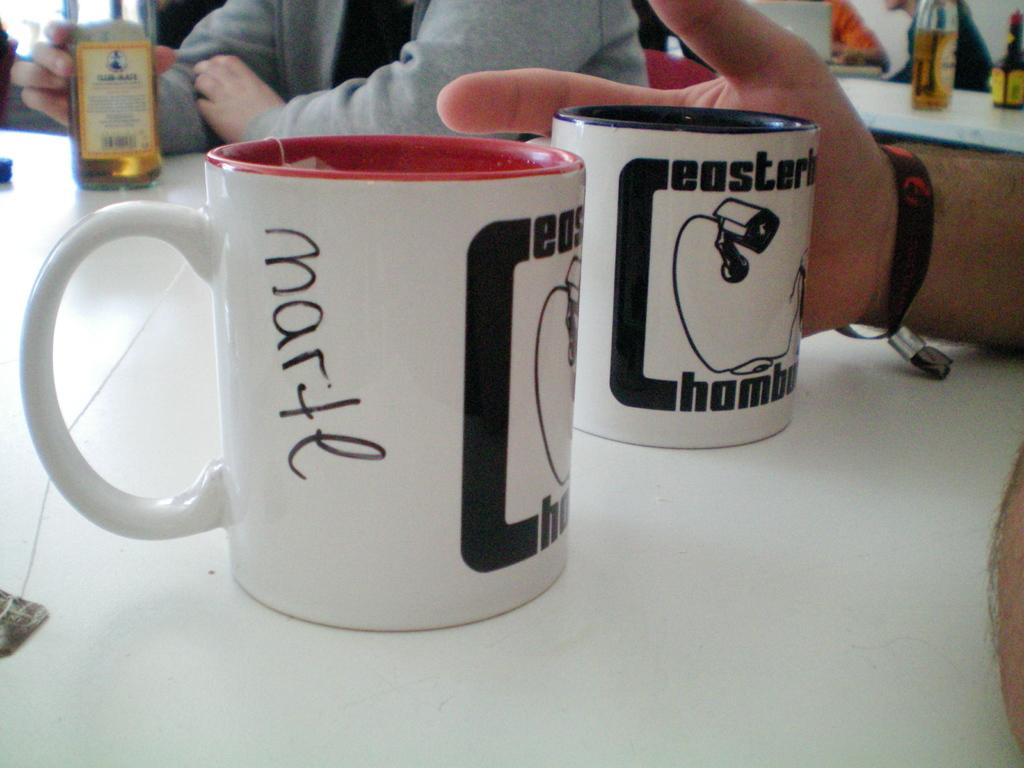<image>
Give a short and clear explanation of the subsequent image. A cup with the word Marte written on it is on a table next to another cup. 